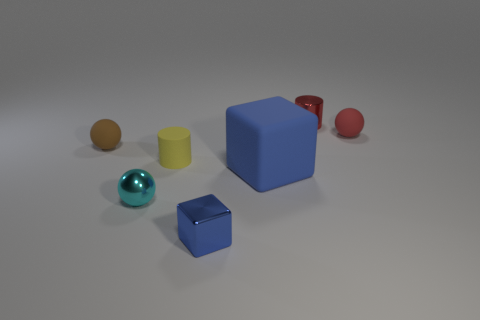What number of tiny matte objects are in front of the rubber ball that is on the left side of the tiny blue cube?
Give a very brief answer. 1. Does the blue object that is behind the tiny block have the same shape as the small metal object that is behind the tiny yellow rubber object?
Your answer should be very brief. No. What shape is the matte object that is the same color as the metal cylinder?
Provide a succinct answer. Sphere. Are there any large objects that have the same material as the cyan ball?
Give a very brief answer. No. How many shiny objects are either tiny cyan balls or red spheres?
Offer a terse response. 1. There is a thing behind the rubber ball that is right of the tiny red metallic thing; what is its shape?
Your answer should be compact. Cylinder. Is the number of cyan metallic objects to the right of the big rubber cube less than the number of cyan spheres?
Make the answer very short. Yes. What shape is the small red matte object?
Provide a succinct answer. Sphere. What size is the matte sphere that is to the right of the brown matte sphere?
Give a very brief answer. Small. The rubber cylinder that is the same size as the cyan metal object is what color?
Offer a very short reply. Yellow. 